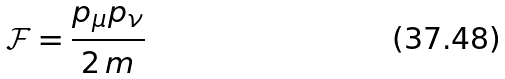Convert formula to latex. <formula><loc_0><loc_0><loc_500><loc_500>\mathcal { F } = \frac { p _ { \mu } p _ { \nu } } { 2 \, m }</formula> 